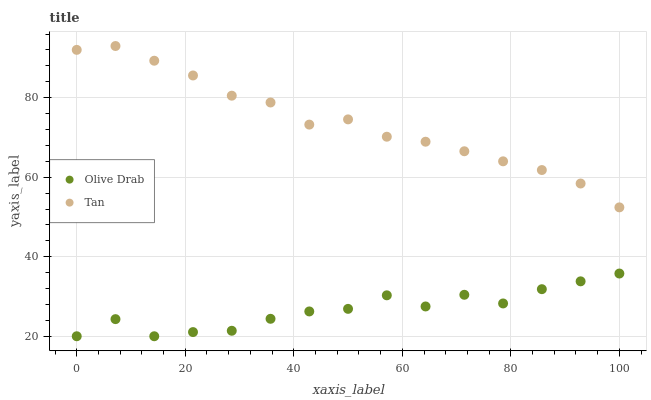Does Olive Drab have the minimum area under the curve?
Answer yes or no. Yes. Does Tan have the maximum area under the curve?
Answer yes or no. Yes. Does Olive Drab have the maximum area under the curve?
Answer yes or no. No. Is Tan the smoothest?
Answer yes or no. Yes. Is Olive Drab the roughest?
Answer yes or no. Yes. Is Olive Drab the smoothest?
Answer yes or no. No. Does Olive Drab have the lowest value?
Answer yes or no. Yes. Does Tan have the highest value?
Answer yes or no. Yes. Does Olive Drab have the highest value?
Answer yes or no. No. Is Olive Drab less than Tan?
Answer yes or no. Yes. Is Tan greater than Olive Drab?
Answer yes or no. Yes. Does Olive Drab intersect Tan?
Answer yes or no. No. 